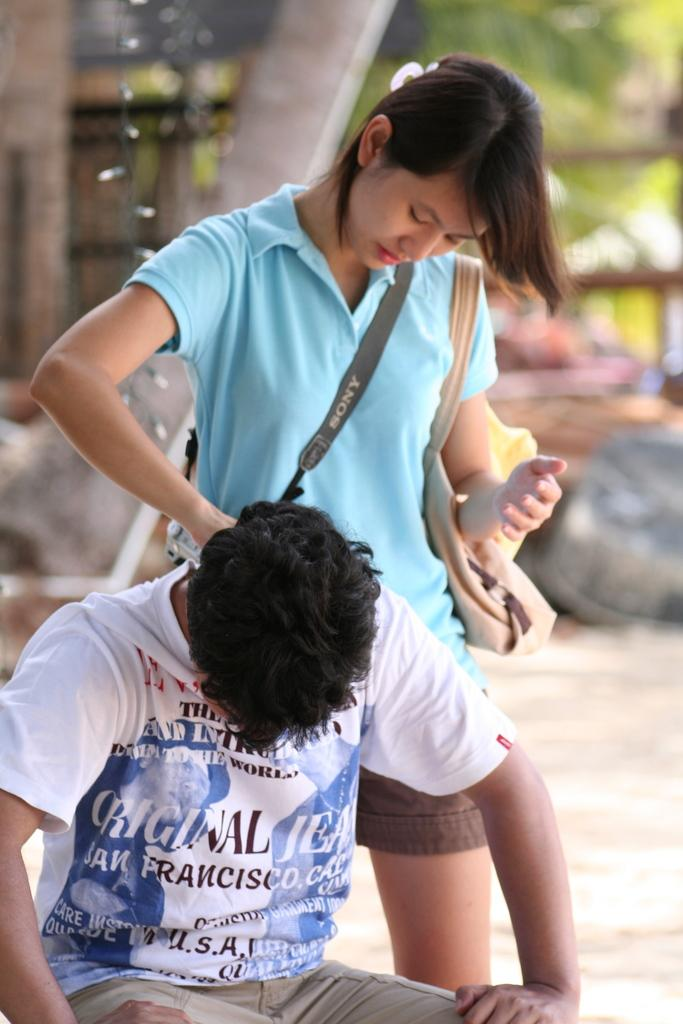How many people are in the image? There are two people in the image. What is the position of one of the people? One person is standing. What is the standing person wearing? The standing person is wearing a bag. What is the standing person doing? The standing person is looking at the other person. How would you describe the background of the image? The background of the image is blurred. How many children are present in the image? There is no mention of children in the image; there are only two people. What type of vegetable is being held by the standing person? There is no vegetable present in the image. 